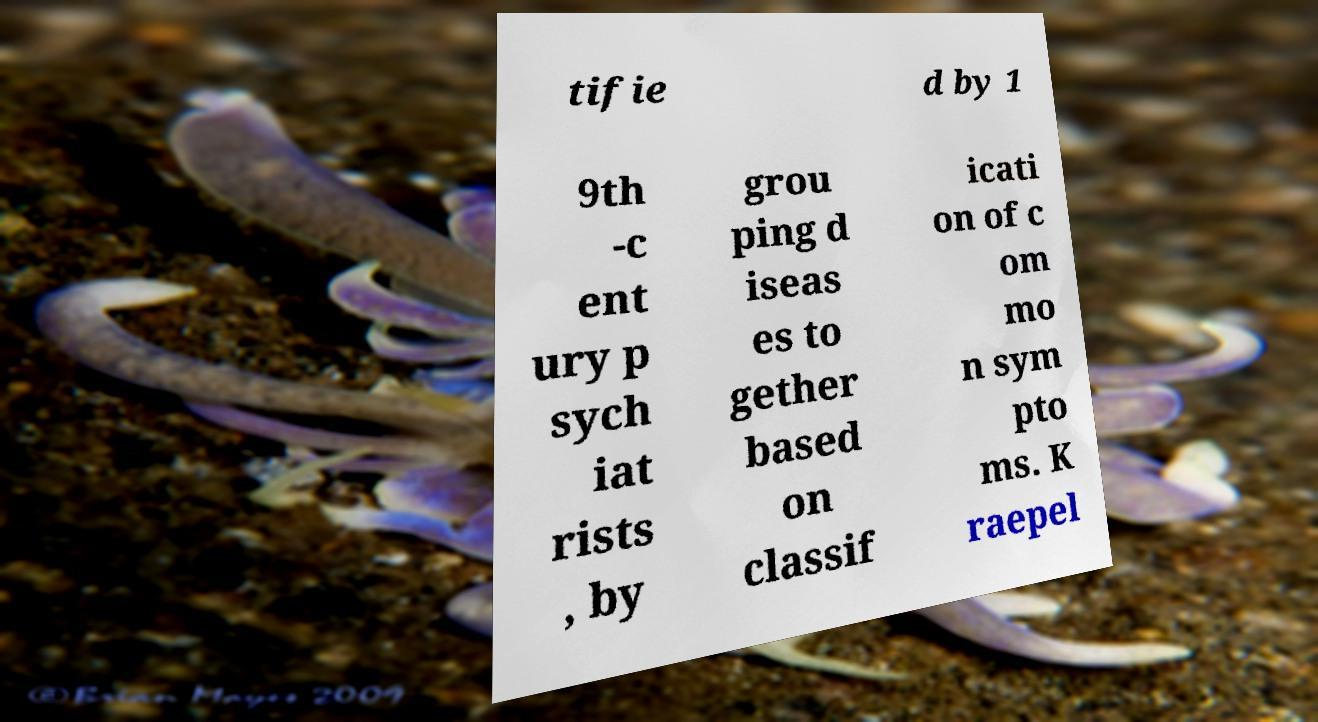There's text embedded in this image that I need extracted. Can you transcribe it verbatim? tifie d by 1 9th -c ent ury p sych iat rists , by grou ping d iseas es to gether based on classif icati on of c om mo n sym pto ms. K raepel 